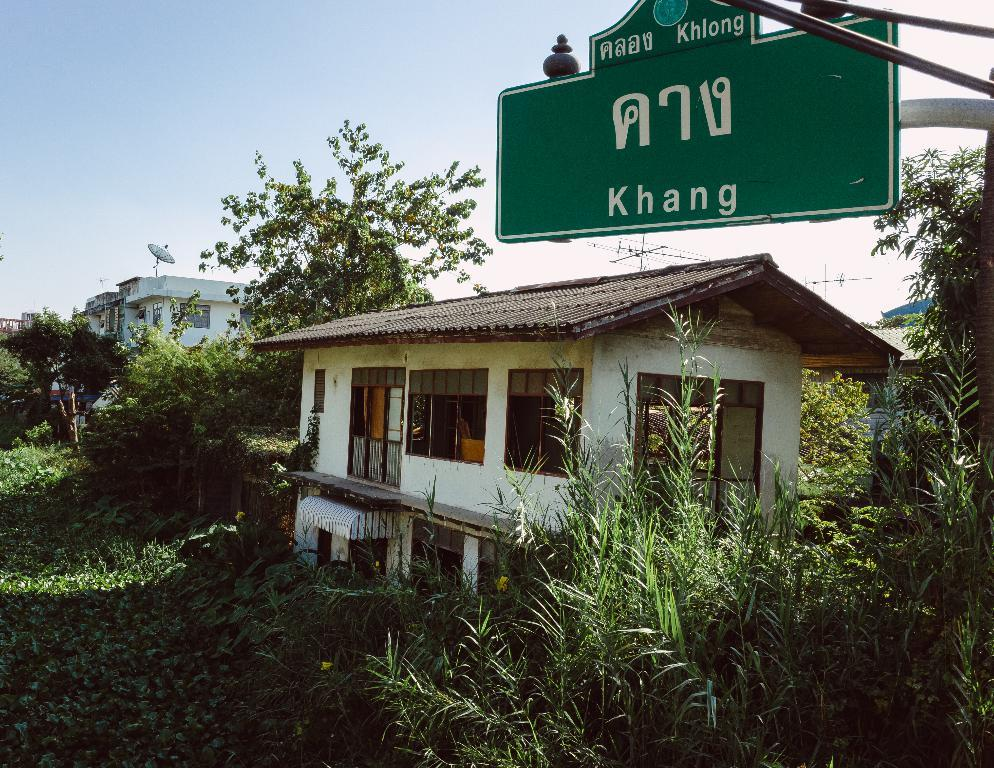What type of structures can be seen in the image? There are buildings in the image. What else is present in the image besides the buildings? There is a sign pole, trees, grass, current poles, and the sky visible in the image. Can you describe the natural elements in the image? There are trees and grass in the image. What is visible at the top of the image? The sky is visible at the top of the image. How does the fog affect the visibility of the buildings in the image? There is no fog present in the image, so its effect on the visibility of the buildings cannot be determined. 